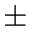<formula> <loc_0><loc_0><loc_500><loc_500>\pm</formula> 